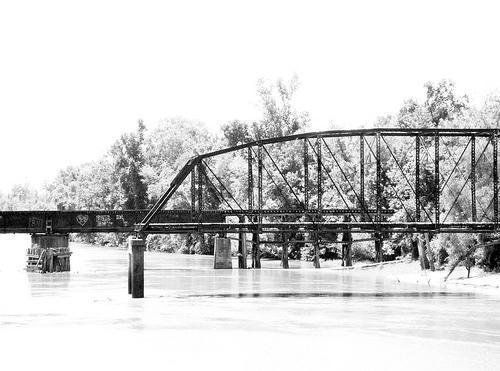How many bridges are there?
Give a very brief answer. 1. 